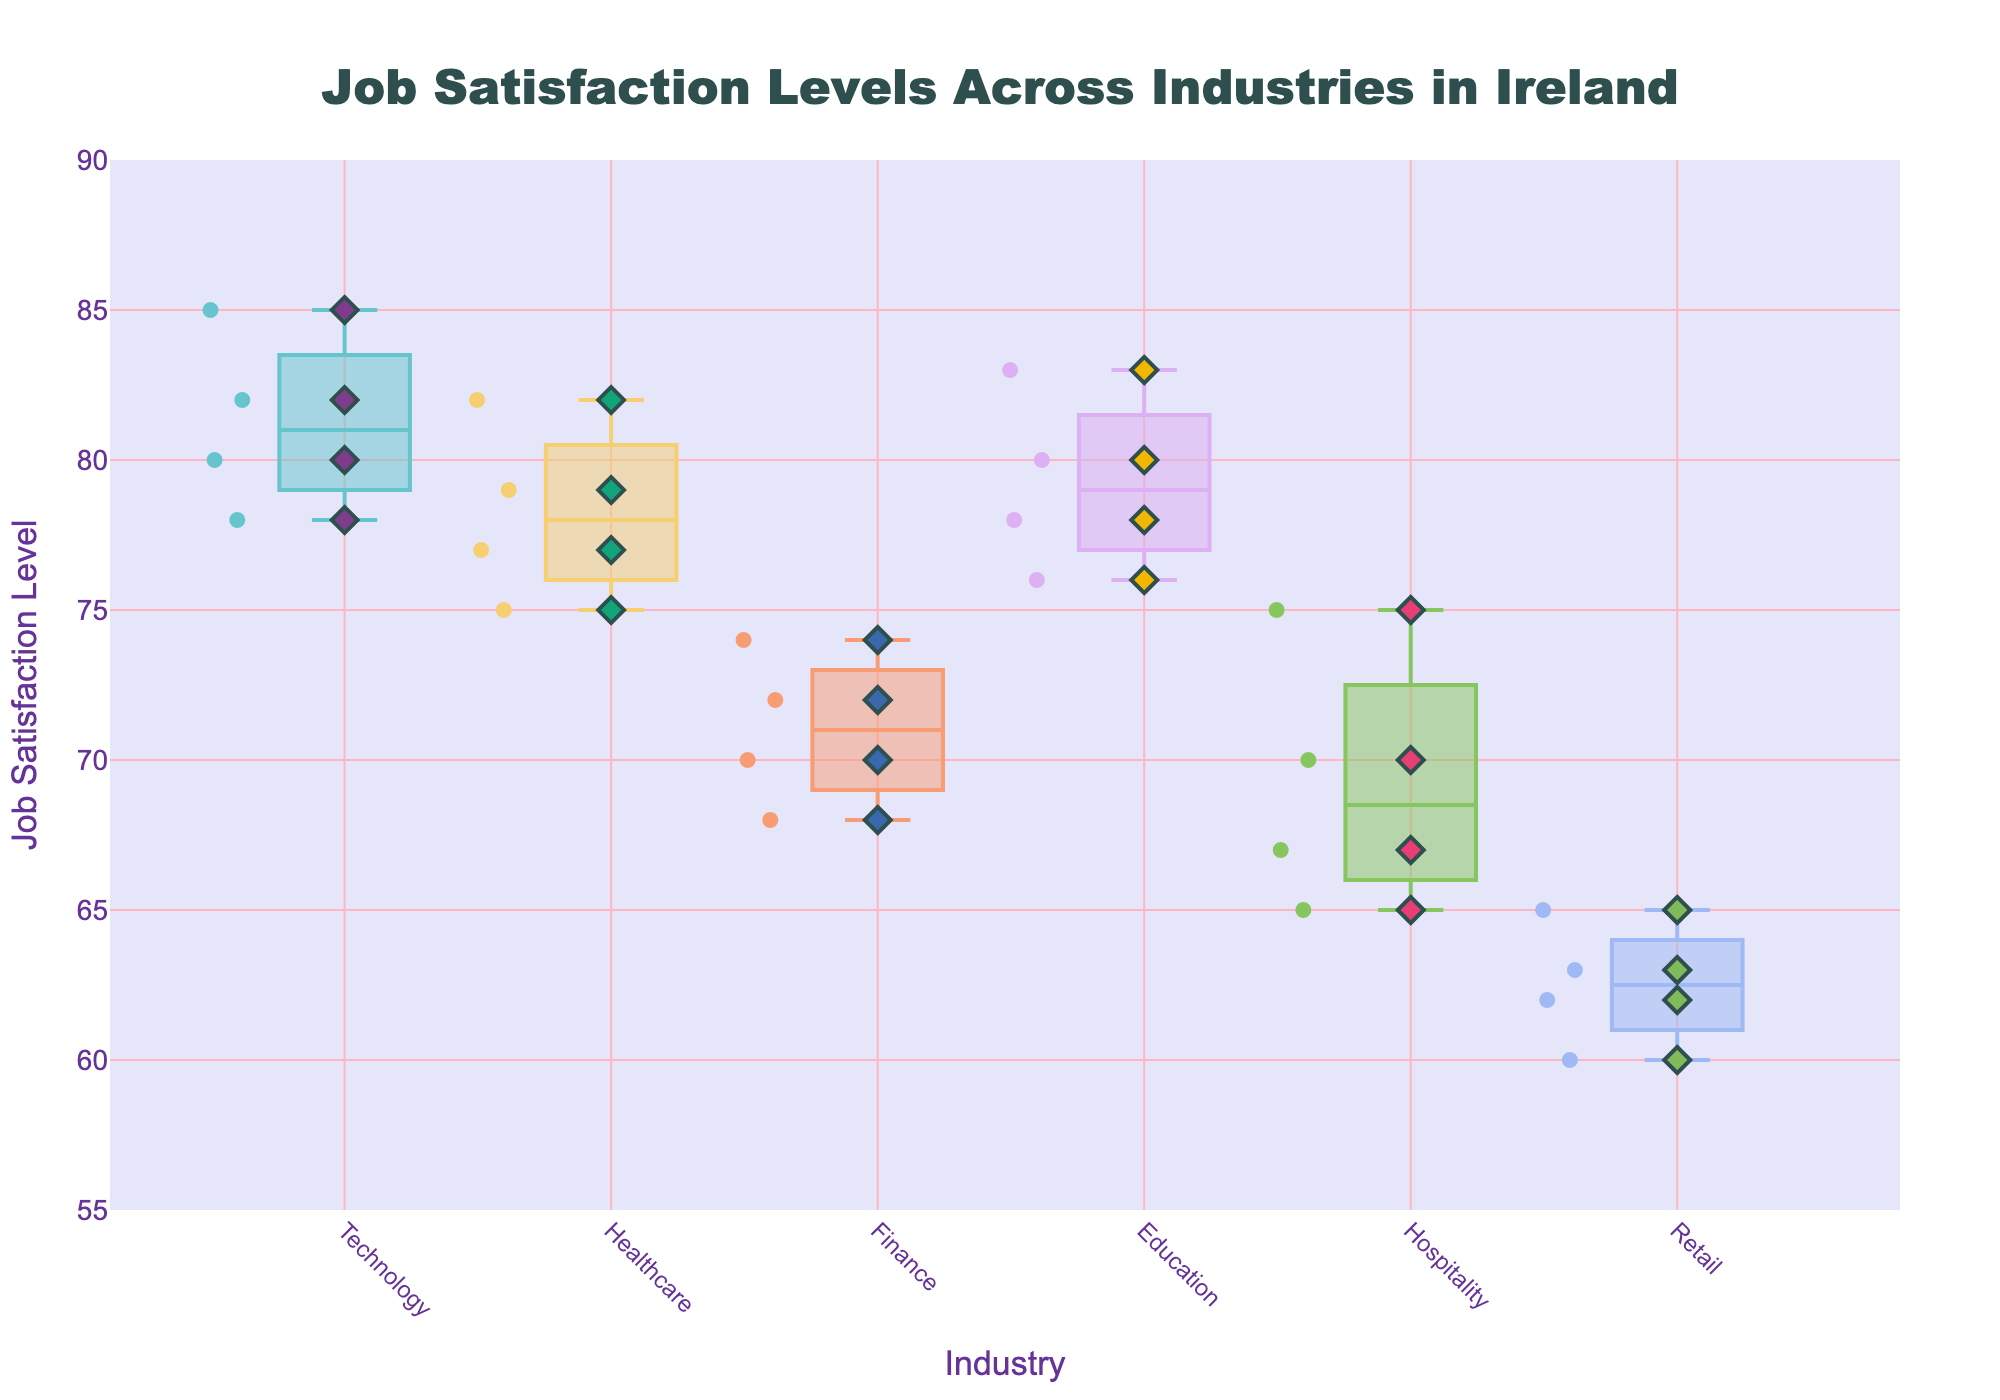what is the average Job Satisfaction Level in the Healthcare industry? There are 4 data points in the Healthcare industry (St. James's Hospital: 77, Beacon Hospital: 82, Mater Misericordiae University Hospital: 75, Cork University Hospital: 79). Sum them up: 77 + 82 + 75 + 79 = 313. Then divide by the number of data points: 313/4 = 78.25
Answer: 78.25 Which industry has the highest median Job Satisfaction Level? The box plot shows the median as the middle line in the box. By comparing the median lines, Education has the highest median Job Satisfaction Level.
Answer: Education How many companies are in the Retail industry? Count the number of data points (scatter points) in the Retail industry. There are 4 scatter points indicating 4 companies: Penneys, Dunnes Stores, Tesco Ireland, SuperValu.
Answer: 4 Which company in the Technology industry has the highest Job Satisfaction Level? Look for scatter points in the Technology box plot and their corresponding hover text. Google has the highest Job Satisfaction Level of 85.
Answer: Google Is the Job Satisfaction Level more variable in Retail or Finance? Compare the spread of the box plots and the scatter points' positions. Retail has a wider spread of data points and a bigger interquartile range compared to Finance, indicating more variability in Job Satisfaction Level.
Answer: Retail What is the range of Job Satisfaction Levels in the Education industry? Identify the smallest and largest values from the Education industry scatter points. The smallest value is 76 (NUI Galway), and the largest value is 83 (Trinity College Dublin). The range is 83 - 76 = 7.
Answer: 7 If you were interested in a stable job satisfaction, which industry should you avoid? Industries with wide spreads in the box plots and scattered points indicate variability. Retail has the highest variability.
Answer: Retail What’s the interquartile range (IQR) for the Technology industry? The IQR is the distance between the first (Q1) and third quartiles (Q3), represented by the lower and upper boundaries of the box. From the plot, Q3 is around 82, and Q1 is around 78. IQR = Q3 - Q1 = 82 - 78 = 4.
Answer: 4 Which industry has a noticeable outlier? An outlier point that stands alone outside the general range of the data is discernible in the Hospitality industry.
Answer: Hospitality Compare the medians of the Healthcare and Finance industries. Which one is higher? Examine the middle lines in the box plots of both industries. The median for Healthcare is around 78, while for Finance, it is around 71. Therefore, the median for Healthcare is higher.
Answer: Healthcare 